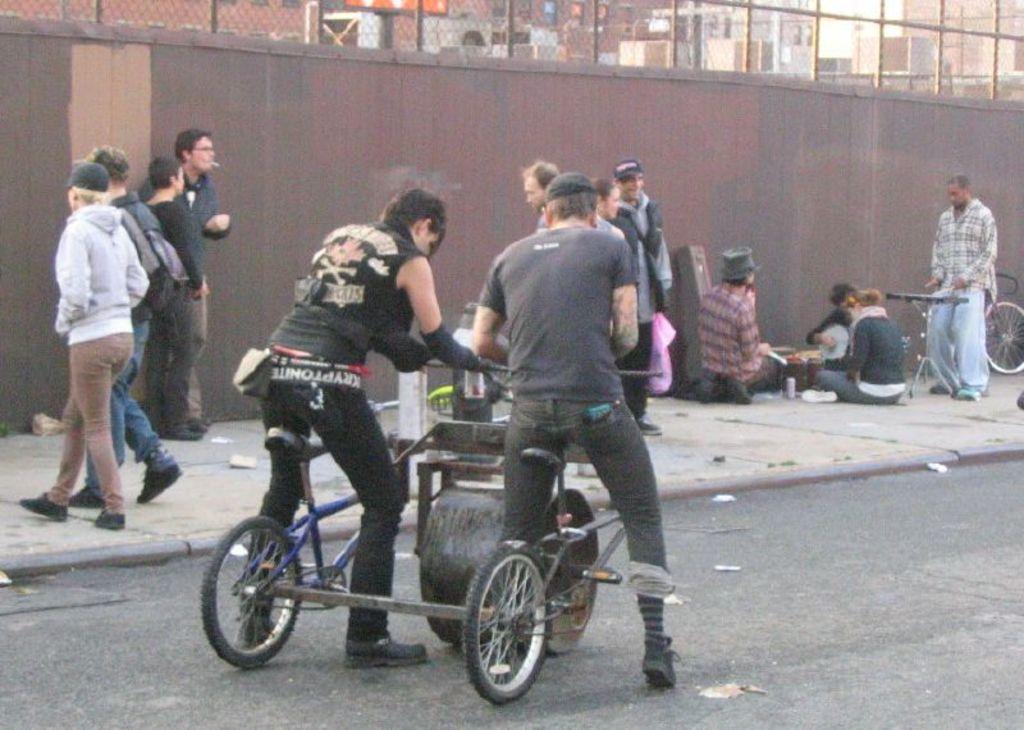Please provide a concise description of this image. In this image I can see the road, a vehicle on the road and on it I can see two persons sitting. I can see the sidewalk, few persons on the sidewalk, the wall, the fencing, few buildings and the sky. 